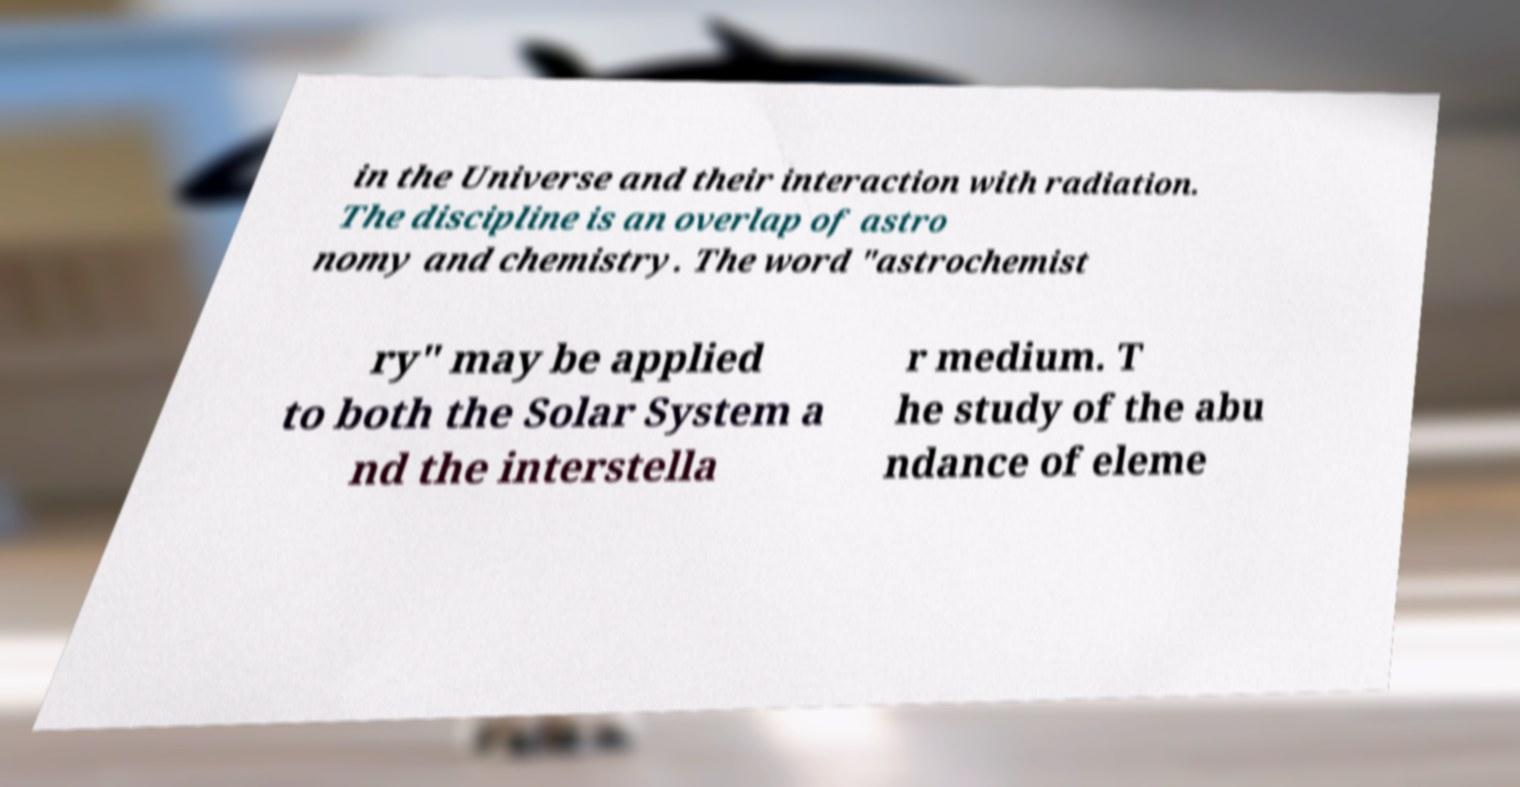Can you accurately transcribe the text from the provided image for me? in the Universe and their interaction with radiation. The discipline is an overlap of astro nomy and chemistry. The word "astrochemist ry" may be applied to both the Solar System a nd the interstella r medium. T he study of the abu ndance of eleme 